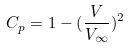Convert formula to latex. <formula><loc_0><loc_0><loc_500><loc_500>C _ { p } = 1 - ( \frac { V } { V _ { \infty } } ) ^ { 2 }</formula> 